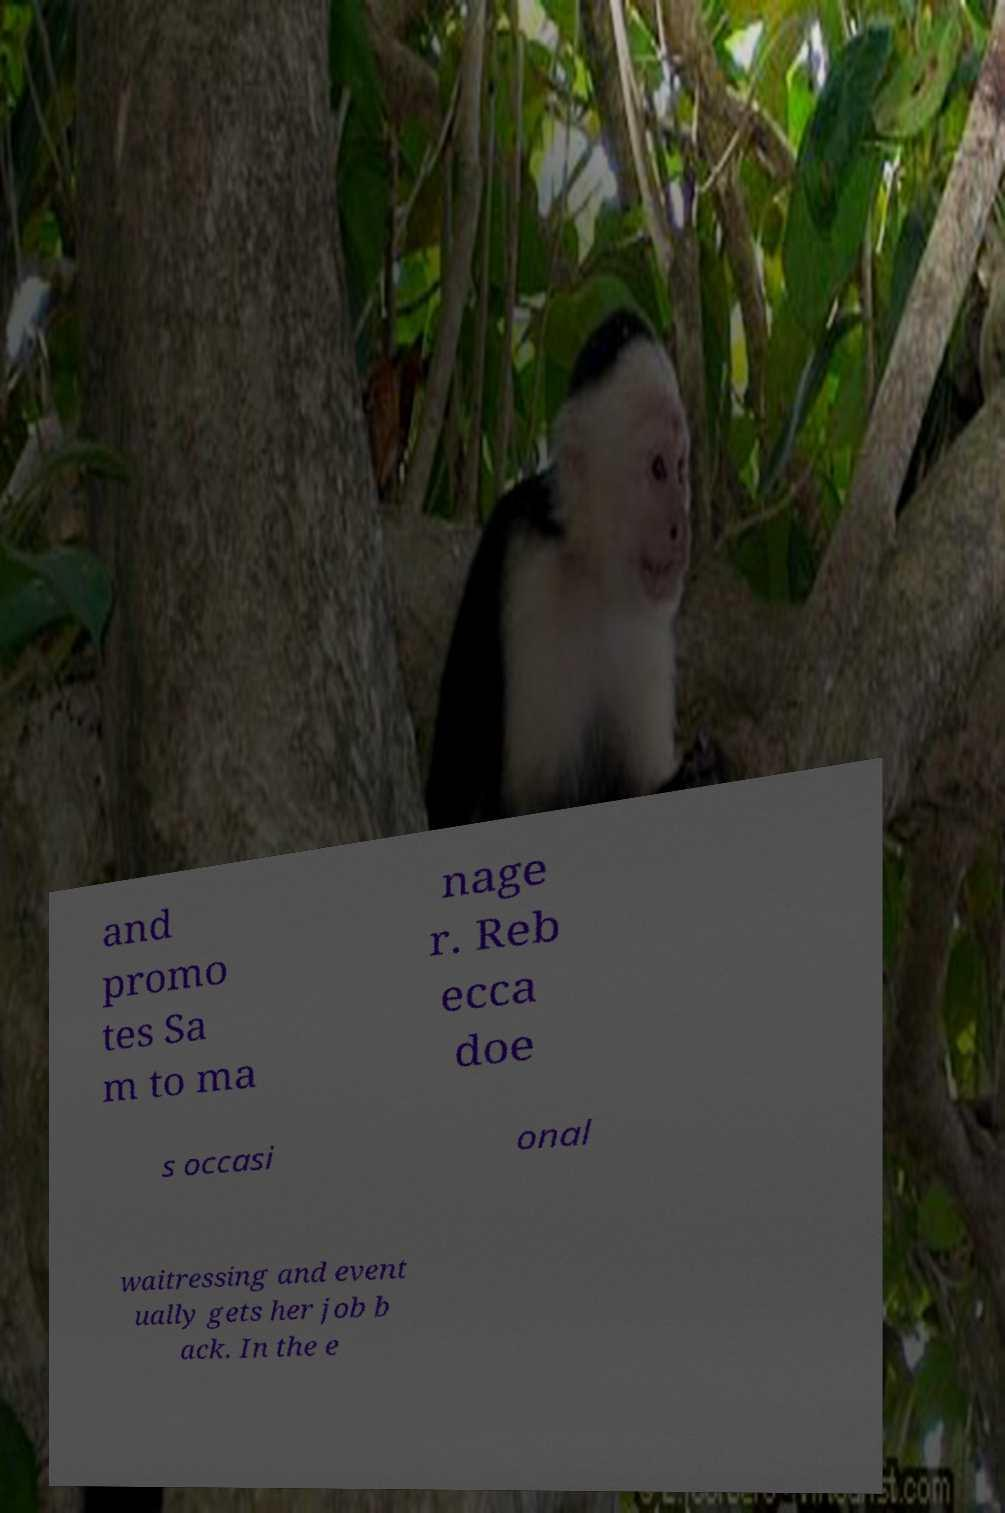Please identify and transcribe the text found in this image. and promo tes Sa m to ma nage r. Reb ecca doe s occasi onal waitressing and event ually gets her job b ack. In the e 